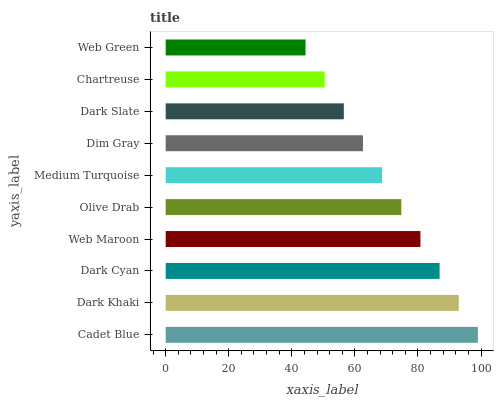Is Web Green the minimum?
Answer yes or no. Yes. Is Cadet Blue the maximum?
Answer yes or no. Yes. Is Dark Khaki the minimum?
Answer yes or no. No. Is Dark Khaki the maximum?
Answer yes or no. No. Is Cadet Blue greater than Dark Khaki?
Answer yes or no. Yes. Is Dark Khaki less than Cadet Blue?
Answer yes or no. Yes. Is Dark Khaki greater than Cadet Blue?
Answer yes or no. No. Is Cadet Blue less than Dark Khaki?
Answer yes or no. No. Is Olive Drab the high median?
Answer yes or no. Yes. Is Medium Turquoise the low median?
Answer yes or no. Yes. Is Web Maroon the high median?
Answer yes or no. No. Is Web Green the low median?
Answer yes or no. No. 